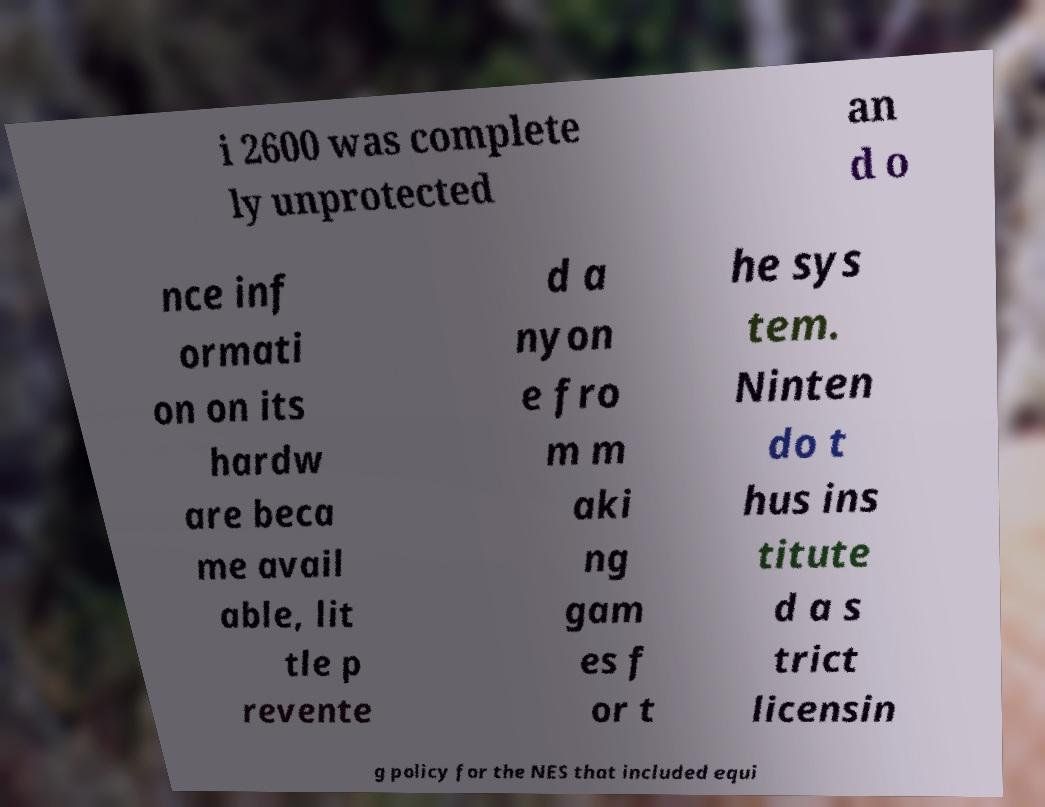Can you accurately transcribe the text from the provided image for me? i 2600 was complete ly unprotected an d o nce inf ormati on on its hardw are beca me avail able, lit tle p revente d a nyon e fro m m aki ng gam es f or t he sys tem. Ninten do t hus ins titute d a s trict licensin g policy for the NES that included equi 